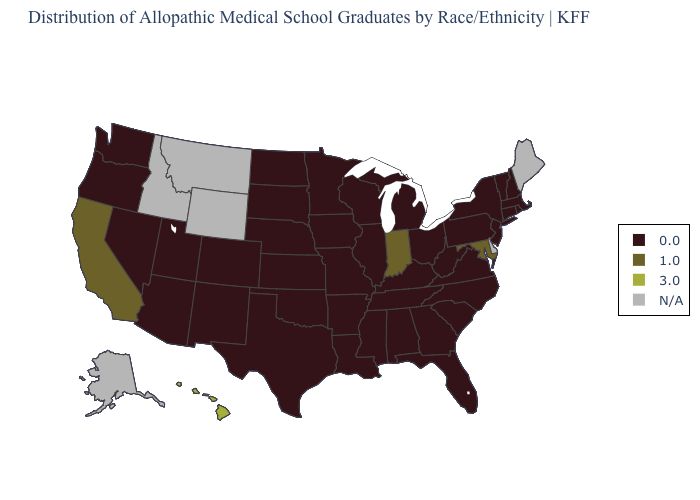What is the value of Oklahoma?
Answer briefly. 0.0. Which states have the lowest value in the USA?
Be succinct. Alabama, Arizona, Arkansas, Colorado, Connecticut, Florida, Georgia, Illinois, Iowa, Kansas, Kentucky, Louisiana, Massachusetts, Michigan, Minnesota, Mississippi, Missouri, Nebraska, Nevada, New Hampshire, New Jersey, New Mexico, New York, North Carolina, North Dakota, Ohio, Oklahoma, Oregon, Pennsylvania, Rhode Island, South Carolina, South Dakota, Tennessee, Texas, Utah, Vermont, Virginia, Washington, West Virginia, Wisconsin. What is the value of Maine?
Give a very brief answer. N/A. Among the states that border Louisiana , which have the lowest value?
Short answer required. Arkansas, Mississippi, Texas. What is the lowest value in states that border Arizona?
Write a very short answer. 0.0. Which states hav the highest value in the South?
Concise answer only. Maryland. Name the states that have a value in the range 1.0?
Give a very brief answer. California, Indiana, Maryland. Does Hawaii have the highest value in the USA?
Be succinct. Yes. What is the value of Oklahoma?
Short answer required. 0.0. Is the legend a continuous bar?
Give a very brief answer. No. What is the lowest value in the USA?
Quick response, please. 0.0. 